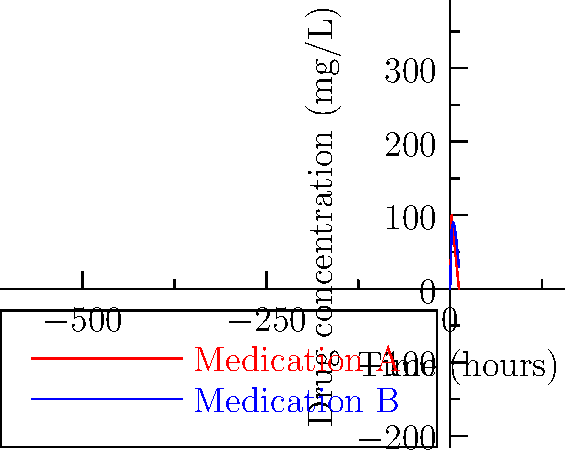The graph shows the concentration of two medications, A and B, in a patient's bloodstream over time. Which medication maintains a higher concentration in the patient's system for a longer period, and at what time do the concentrations of the two medications become equal? To answer this question, we need to analyze the graph step-by-step:

1. Observe the two curves:
   - Red curve represents Medication A
   - Blue curve represents Medication B

2. Compare the overall trends:
   - Medication A starts higher but decreases more rapidly
   - Medication B starts lower but maintains a higher concentration over time

3. Determine which medication maintains a higher concentration for longer:
   - After the 2-hour mark, Medication B's concentration is consistently higher than Medication A
   - Therefore, Medication B maintains a higher concentration for a longer period

4. Find the intersection point of the two curves:
   - This is where the concentrations of both medications are equal
   - Visually, this occurs between 1 and 2 hours

5. Estimate the exact time of intersection:
   - At 1 hour (halfway between 0 and 2), Medication A would be around 90 mg/L, Medication B around 40 mg/L
   - At 2 hours, Medication A is at 100 mg/L, Medication B at 80 mg/L
   - The intersection appears to be closer to the 2-hour mark, approximately at 1.5 hours

Therefore, Medication B maintains a higher concentration for a longer period, and the concentrations become equal at approximately 1.5 hours.
Answer: Medication B; approximately 1.5 hours 